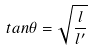Convert formula to latex. <formula><loc_0><loc_0><loc_500><loc_500>t a n \theta = \sqrt { \frac { l } { l ^ { \prime } } }</formula> 